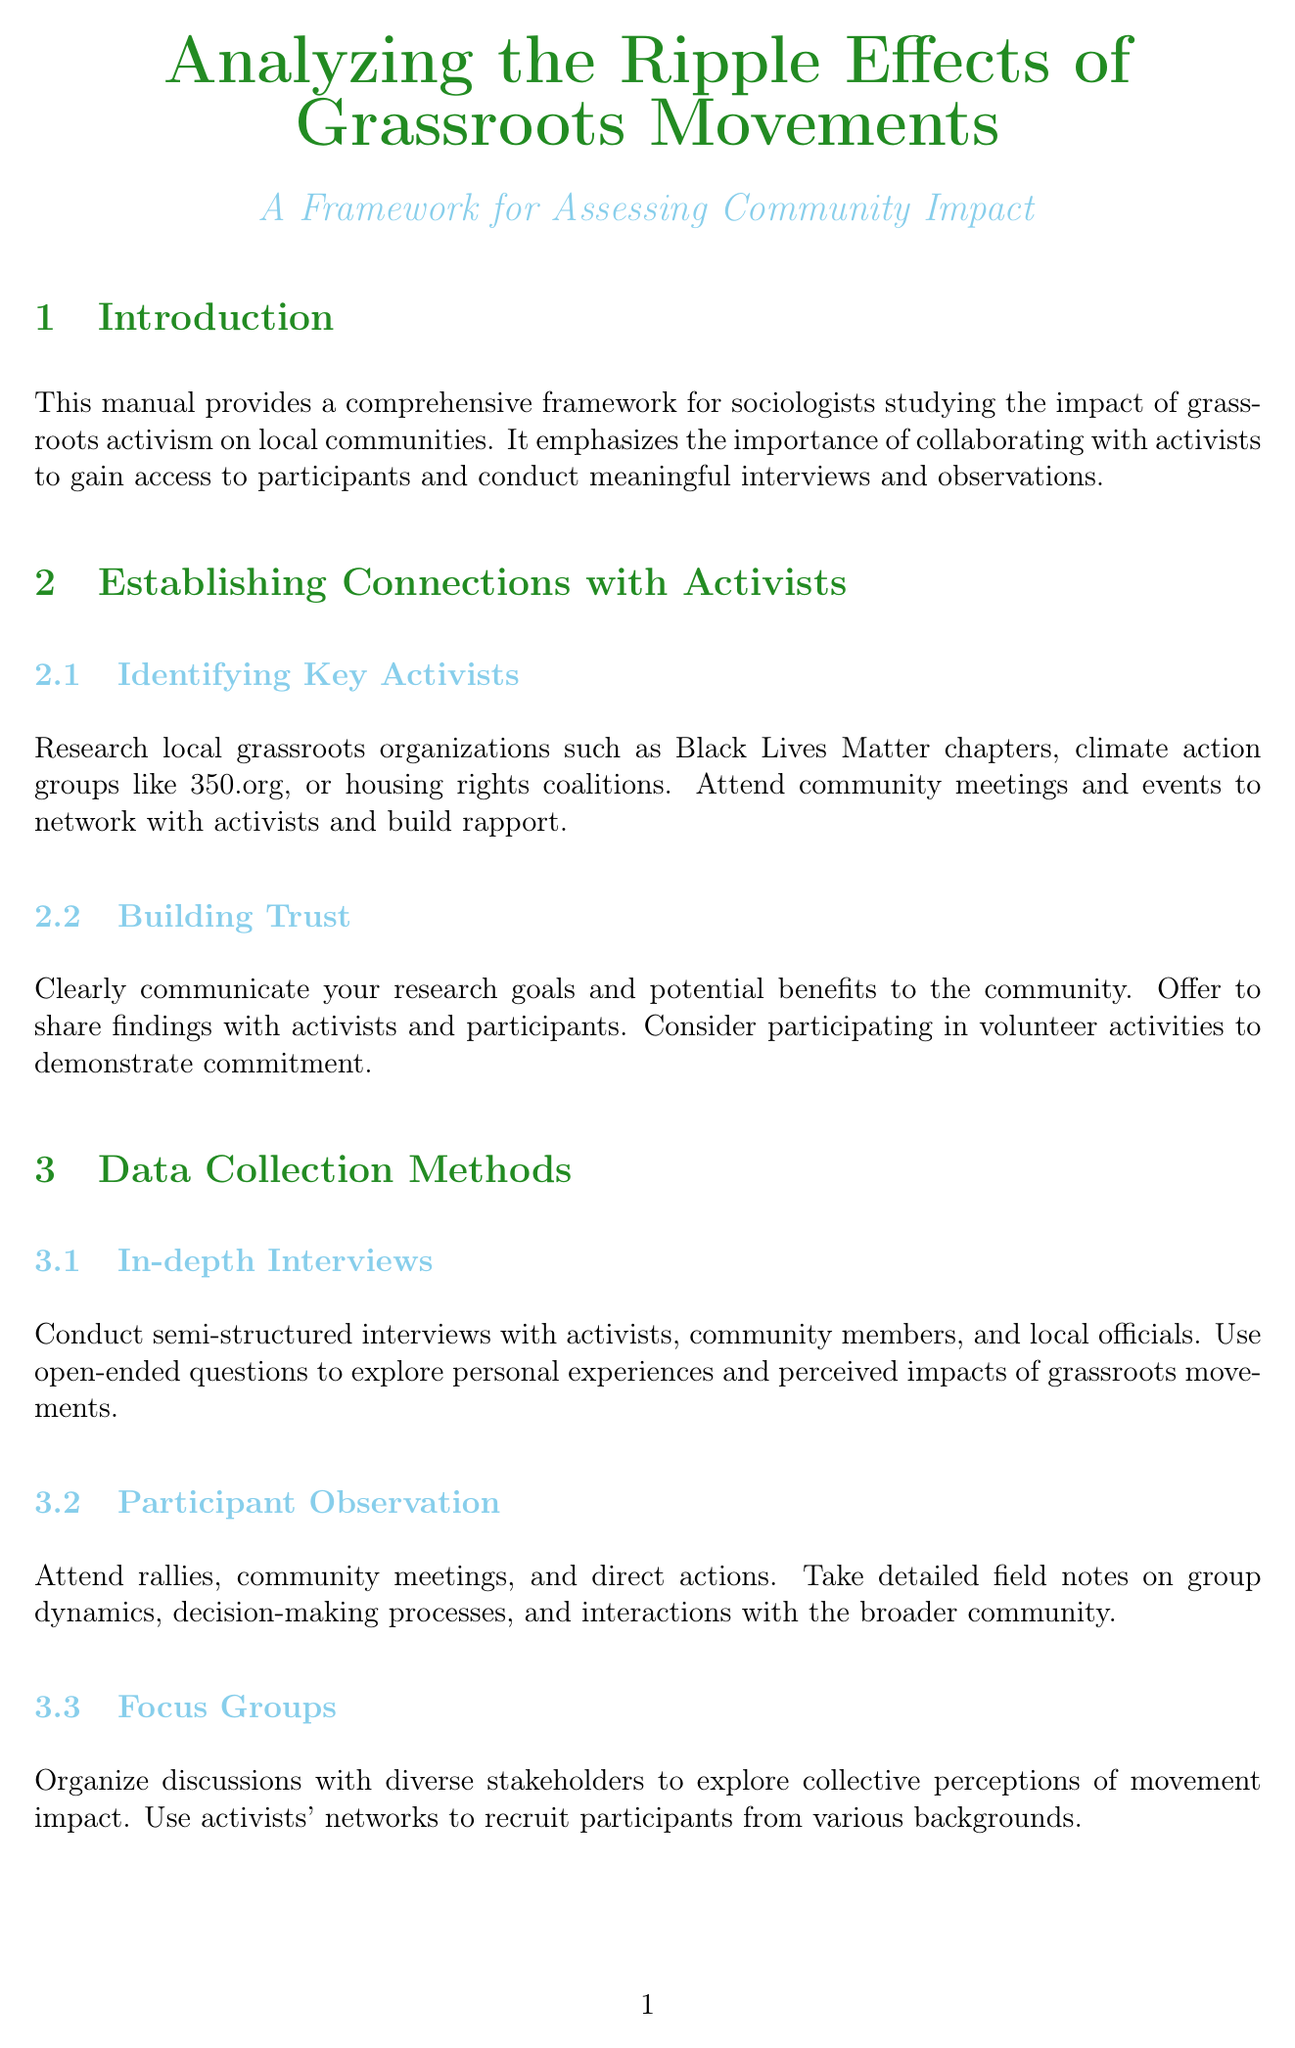What is the title of the manual? The title is stated at the beginning of the document and is "Analyzing the Ripple Effects of Grassroots Movements: A Framework for Assessing Community Impact."
Answer: Analyzing the Ripple Effects of Grassroots Movements: A Framework for Assessing Community Impact What is one method of data collection mentioned in the manual? The document lists several methods of data collection, one of which is "In-depth Interviews."
Answer: In-depth Interviews Who should be identified to establish connections with activists? The subsection highlights the importance of identifying "Key Activists" such as those in local grassroots organizations.
Answer: Key Activists What is a focus of assessing community impact? The document outlines various focuses, one of which is "Social Capital."
Answer: Social Capital What is required to ensure ethical research practices? The manual emphasizes the importance of "Informed Consent" to respect participants' rights.
Answer: Informed Consent Which software can be used for coding and thematic analysis? The document suggests using qualitative data analysis software like "NVivo or ATLAS.ti."
Answer: NVivo or ATLAS.ti How can findings be shared with the community? The document suggests creating "Community Reports" as a way to share findings with community members and activists.
Answer: Community Reports What type of reports can highlight policy-relevant findings? The manual indicates that "Policy Briefs" can be developed for local government officials.
Answer: Policy Briefs 